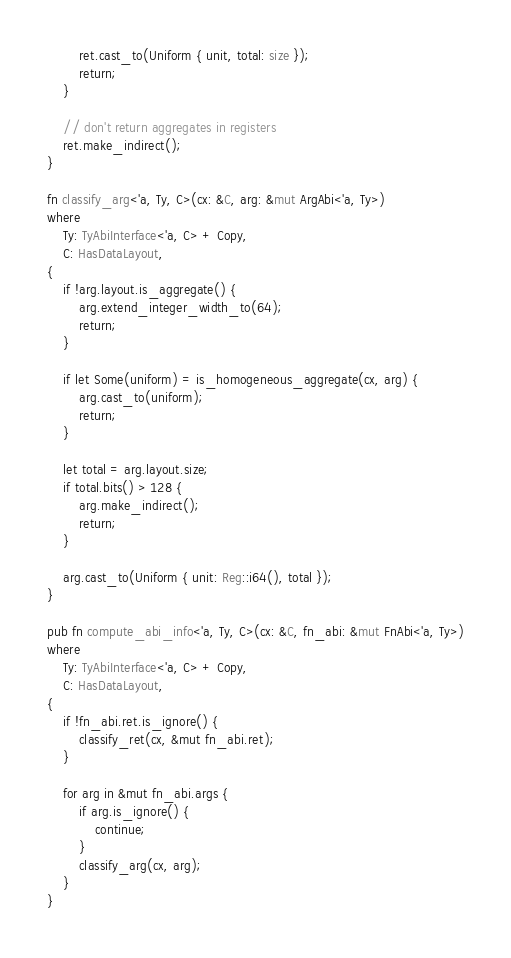<code> <loc_0><loc_0><loc_500><loc_500><_Rust_>        ret.cast_to(Uniform { unit, total: size });
        return;
    }

    // don't return aggregates in registers
    ret.make_indirect();
}

fn classify_arg<'a, Ty, C>(cx: &C, arg: &mut ArgAbi<'a, Ty>)
where
    Ty: TyAbiInterface<'a, C> + Copy,
    C: HasDataLayout,
{
    if !arg.layout.is_aggregate() {
        arg.extend_integer_width_to(64);
        return;
    }

    if let Some(uniform) = is_homogeneous_aggregate(cx, arg) {
        arg.cast_to(uniform);
        return;
    }

    let total = arg.layout.size;
    if total.bits() > 128 {
        arg.make_indirect();
        return;
    }

    arg.cast_to(Uniform { unit: Reg::i64(), total });
}

pub fn compute_abi_info<'a, Ty, C>(cx: &C, fn_abi: &mut FnAbi<'a, Ty>)
where
    Ty: TyAbiInterface<'a, C> + Copy,
    C: HasDataLayout,
{
    if !fn_abi.ret.is_ignore() {
        classify_ret(cx, &mut fn_abi.ret);
    }

    for arg in &mut fn_abi.args {
        if arg.is_ignore() {
            continue;
        }
        classify_arg(cx, arg);
    }
}
</code> 